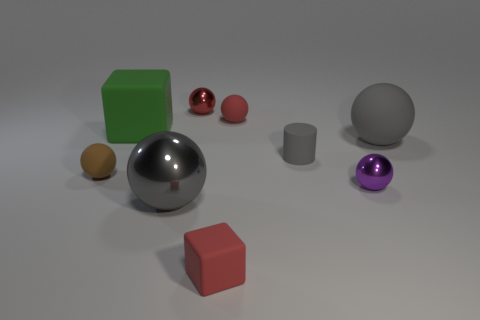There is a matte object that is to the right of the tiny shiny thing to the right of the metal ball that is behind the red matte ball; what is its shape?
Offer a terse response. Sphere. What is the shape of the matte thing that is both behind the gray matte cylinder and to the right of the small red matte sphere?
Provide a short and direct response. Sphere. Are there any purple spheres that have the same material as the small gray cylinder?
Ensure brevity in your answer.  No. There is a matte thing that is the same color as the tiny rubber cylinder; what is its size?
Offer a very short reply. Large. What is the color of the small metal ball behind the tiny red rubber sphere?
Your answer should be very brief. Red. There is a green rubber thing; does it have the same shape as the red thing in front of the large shiny sphere?
Your answer should be compact. Yes. Are there any other large metallic balls that have the same color as the big shiny ball?
Give a very brief answer. No. There is a red object that is the same material as the purple object; what size is it?
Offer a very short reply. Small. Is the color of the tiny cylinder the same as the large matte sphere?
Keep it short and to the point. Yes. Is the shape of the gray rubber thing right of the gray rubber cylinder the same as  the small purple metallic thing?
Offer a terse response. Yes. 